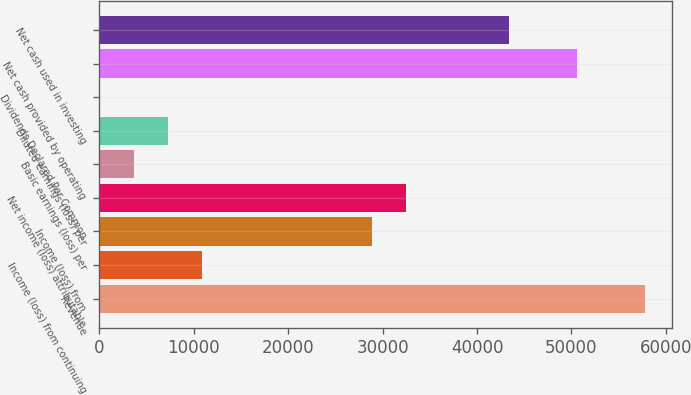Convert chart. <chart><loc_0><loc_0><loc_500><loc_500><bar_chart><fcel>Revenue<fcel>Income (loss) from continuing<fcel>Income (loss) from<fcel>Net income (loss) attributable<fcel>Basic earnings (loss) per<fcel>Diluted earnings (loss) per<fcel>Dividends Declared Per Common<fcel>Net cash provided by operating<fcel>Net cash used in investing<nl><fcel>57798.2<fcel>10837.5<fcel>28899.3<fcel>32511.7<fcel>3612.81<fcel>7225.17<fcel>0.45<fcel>50573.5<fcel>43348.8<nl></chart> 